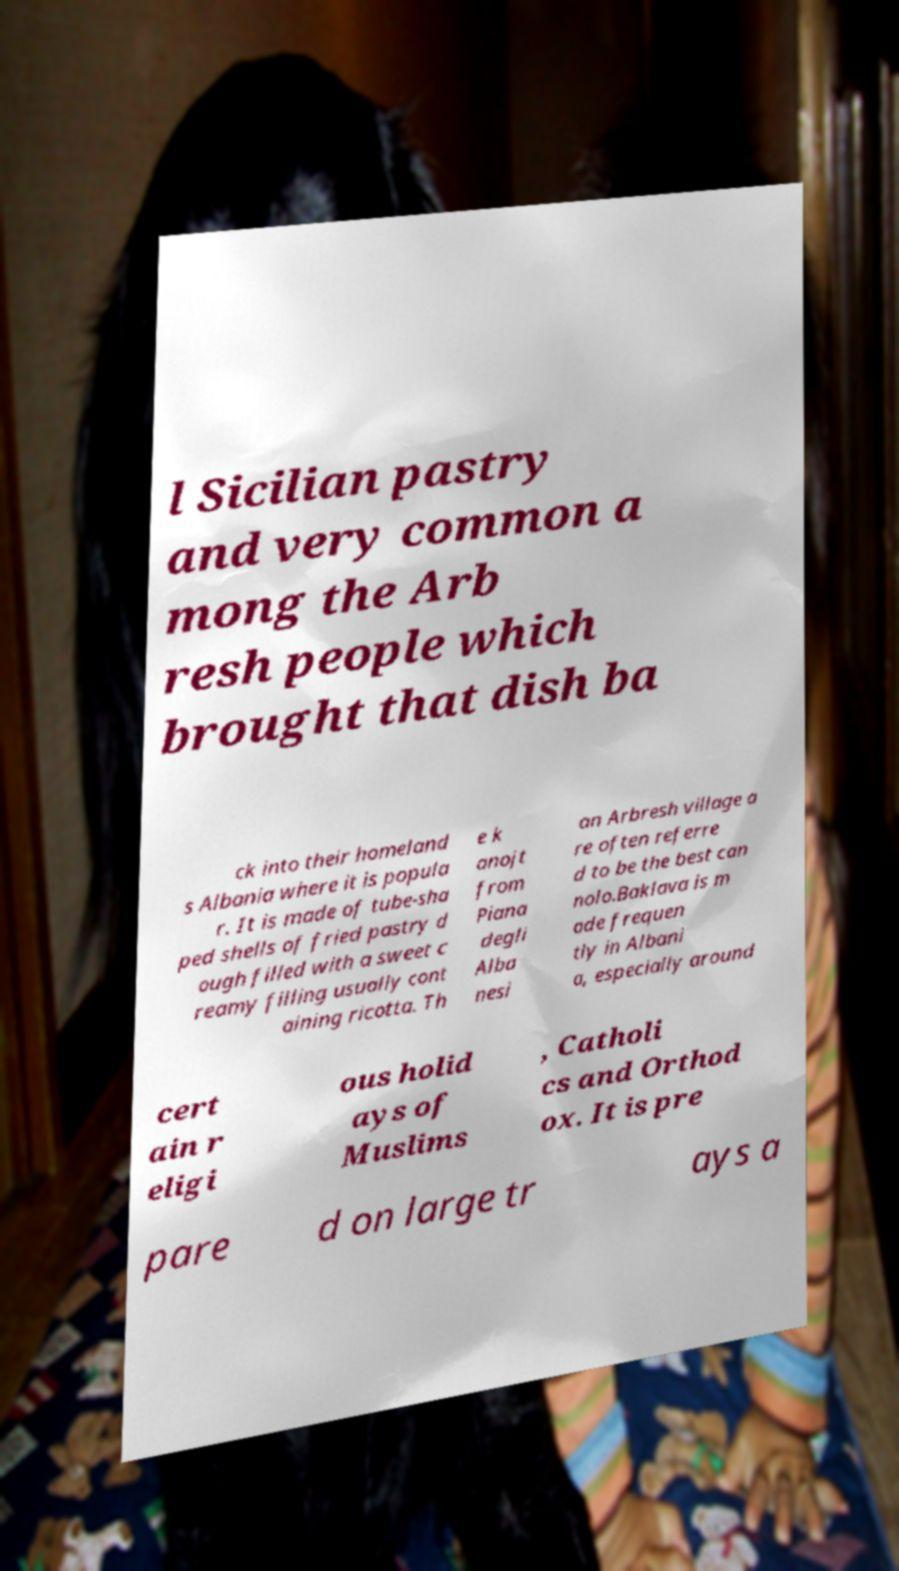Please read and relay the text visible in this image. What does it say? l Sicilian pastry and very common a mong the Arb resh people which brought that dish ba ck into their homeland s Albania where it is popula r. It is made of tube-sha ped shells of fried pastry d ough filled with a sweet c reamy filling usually cont aining ricotta. Th e k anojt from Piana degli Alba nesi an Arbresh village a re often referre d to be the best can nolo.Baklava is m ade frequen tly in Albani a, especially around cert ain r eligi ous holid ays of Muslims , Catholi cs and Orthod ox. It is pre pare d on large tr ays a 